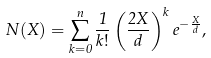Convert formula to latex. <formula><loc_0><loc_0><loc_500><loc_500>N ( X ) = \sum _ { k = 0 } ^ { n } \frac { 1 } { k ! } \left ( \frac { 2 X } { d } \right ) ^ { k } e ^ { - \frac { X } { d } } ,</formula> 